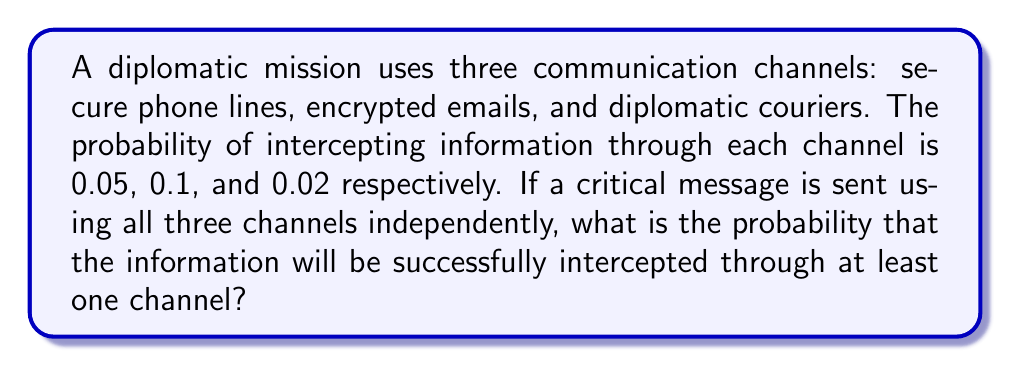Teach me how to tackle this problem. Let's approach this step-by-step:

1) First, let's define our events:
   A: Information intercepted through secure phone lines (P(A) = 0.05)
   B: Information intercepted through encrypted emails (P(B) = 0.1)
   C: Information intercepted through diplomatic couriers (P(C) = 0.02)

2) We need to find the probability of at least one of these events occurring. It's easier to calculate the probability of none of these events occurring and then subtract from 1.

3) The probability of the information not being intercepted through a channel is the complement of it being intercepted:
   P(not A) = 1 - P(A) = 1 - 0.05 = 0.95
   P(not B) = 1 - P(B) = 1 - 0.1 = 0.9
   P(not C) = 1 - P(C) = 1 - 0.02 = 0.98

4) Since the channels are independent, the probability of the information not being intercepted through any channel is the product of these probabilities:

   P(not intercepted) = P(not A) × P(not B) × P(not C)
                      = 0.95 × 0.9 × 0.98
                      = 0.8379

5) Therefore, the probability of the information being intercepted through at least one channel is:

   P(intercepted) = 1 - P(not intercepted)
                  = 1 - 0.8379
                  = 0.1621

6) We can express this as a percentage: 16.21%
Answer: 0.1621 or 16.21% 